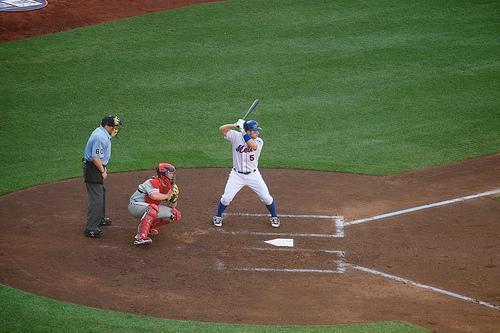How many men are there?
Give a very brief answer. 3. How many players are there?
Give a very brief answer. 2. How many officials are there?
Give a very brief answer. 1. 